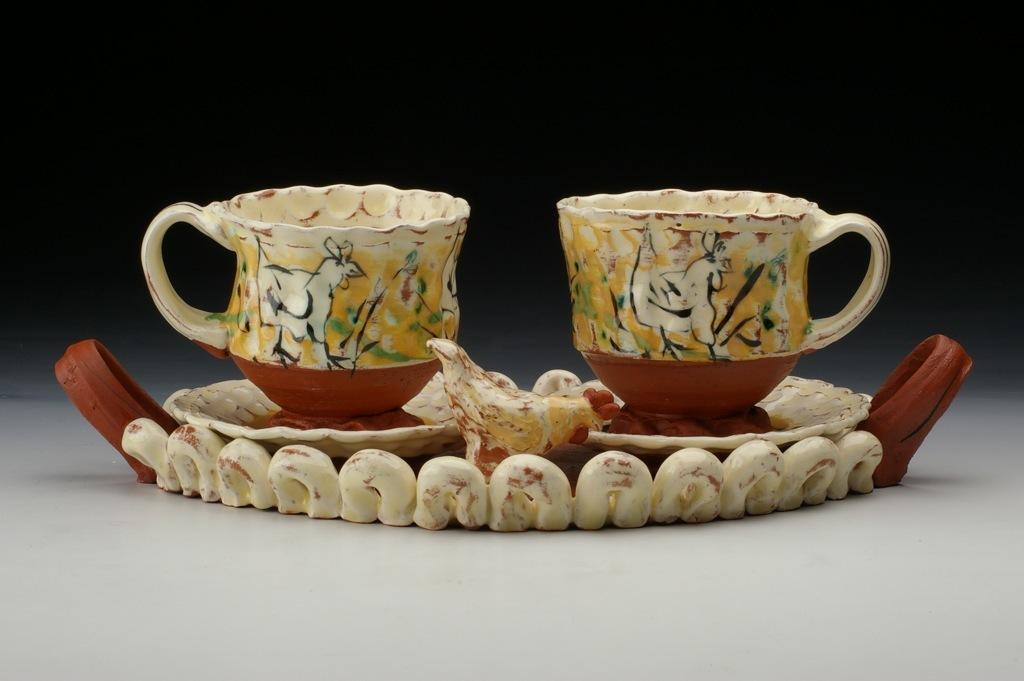Could you give a brief overview of what you see in this image? In this image we can see cups and saucers on the white color surface. 